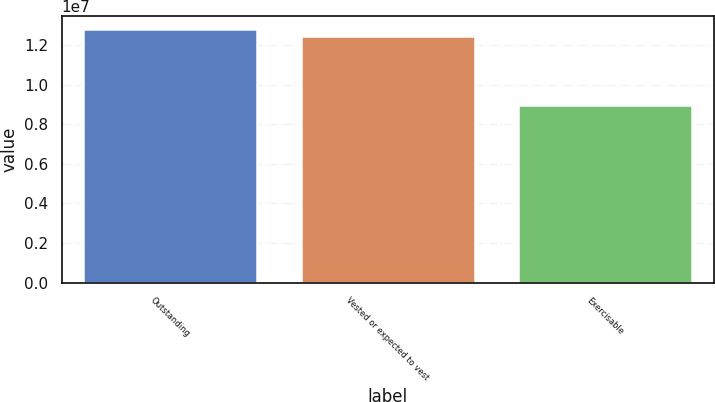Convert chart. <chart><loc_0><loc_0><loc_500><loc_500><bar_chart><fcel>Outstanding<fcel>Vested or expected to vest<fcel>Exercisable<nl><fcel>1.28468e+07<fcel>1.24879e+07<fcel>8.98557e+06<nl></chart> 